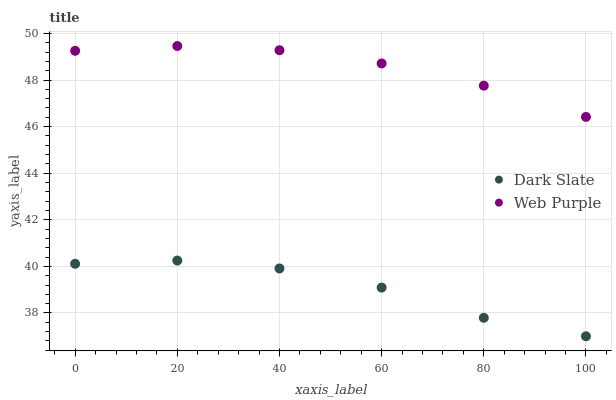Does Dark Slate have the minimum area under the curve?
Answer yes or no. Yes. Does Web Purple have the maximum area under the curve?
Answer yes or no. Yes. Does Web Purple have the minimum area under the curve?
Answer yes or no. No. Is Web Purple the smoothest?
Answer yes or no. Yes. Is Dark Slate the roughest?
Answer yes or no. Yes. Is Web Purple the roughest?
Answer yes or no. No. Does Dark Slate have the lowest value?
Answer yes or no. Yes. Does Web Purple have the lowest value?
Answer yes or no. No. Does Web Purple have the highest value?
Answer yes or no. Yes. Is Dark Slate less than Web Purple?
Answer yes or no. Yes. Is Web Purple greater than Dark Slate?
Answer yes or no. Yes. Does Dark Slate intersect Web Purple?
Answer yes or no. No. 